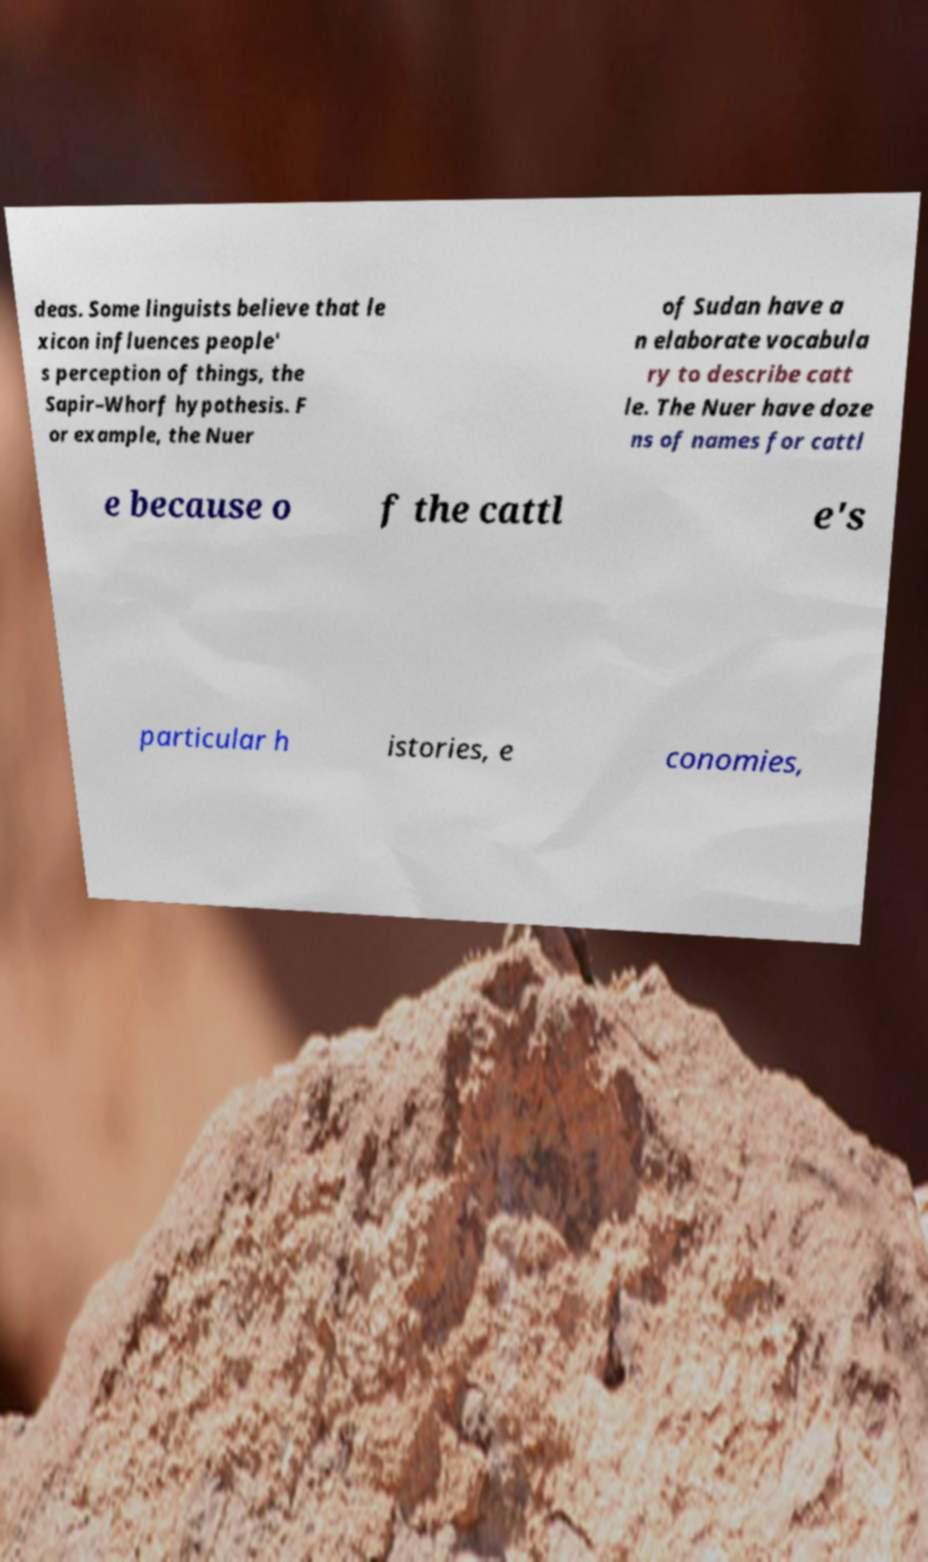Can you accurately transcribe the text from the provided image for me? deas. Some linguists believe that le xicon influences people' s perception of things, the Sapir–Whorf hypothesis. F or example, the Nuer of Sudan have a n elaborate vocabula ry to describe catt le. The Nuer have doze ns of names for cattl e because o f the cattl e's particular h istories, e conomies, 